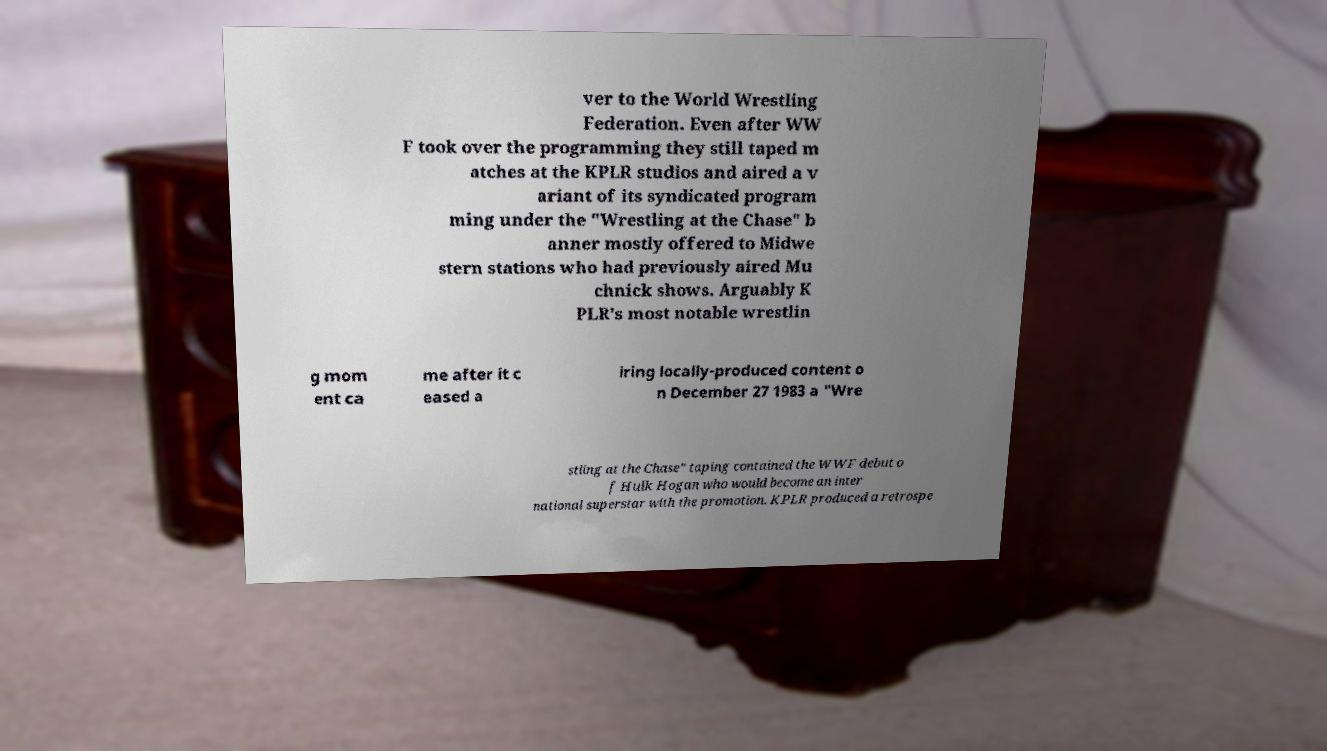Please identify and transcribe the text found in this image. ver to the World Wrestling Federation. Even after WW F took over the programming they still taped m atches at the KPLR studios and aired a v ariant of its syndicated program ming under the "Wrestling at the Chase" b anner mostly offered to Midwe stern stations who had previously aired Mu chnick shows. Arguably K PLR's most notable wrestlin g mom ent ca me after it c eased a iring locally-produced content o n December 27 1983 a "Wre stling at the Chase" taping contained the WWF debut o f Hulk Hogan who would become an inter national superstar with the promotion. KPLR produced a retrospe 